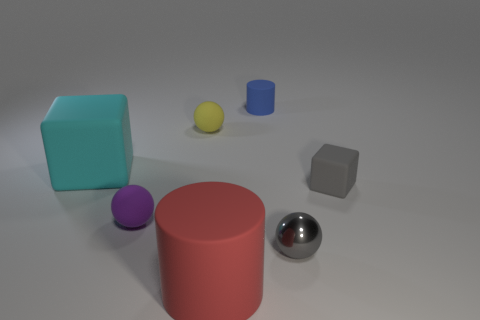Can you describe the setting or atmosphere suggested by the lighting and arrangement of the objects? The soft, diffuse lighting imbues the scene with a quiet, calm atmosphere. The strategic placement of objects with varying sizes, colors, and materials creates a sense of balance and intention, hinting at a possibly staged or curated environment meant for observation or study. 